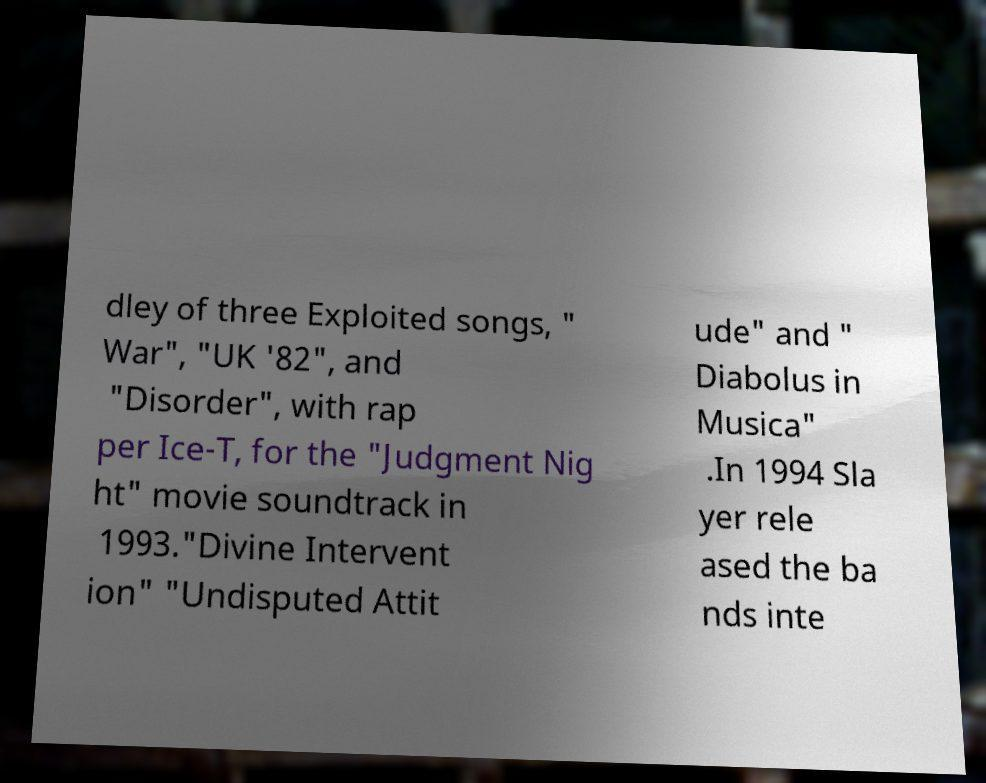Can you read and provide the text displayed in the image?This photo seems to have some interesting text. Can you extract and type it out for me? dley of three Exploited songs, " War", "UK '82", and "Disorder", with rap per Ice-T, for the "Judgment Nig ht" movie soundtrack in 1993."Divine Intervent ion" "Undisputed Attit ude" and " Diabolus in Musica" .In 1994 Sla yer rele ased the ba nds inte 